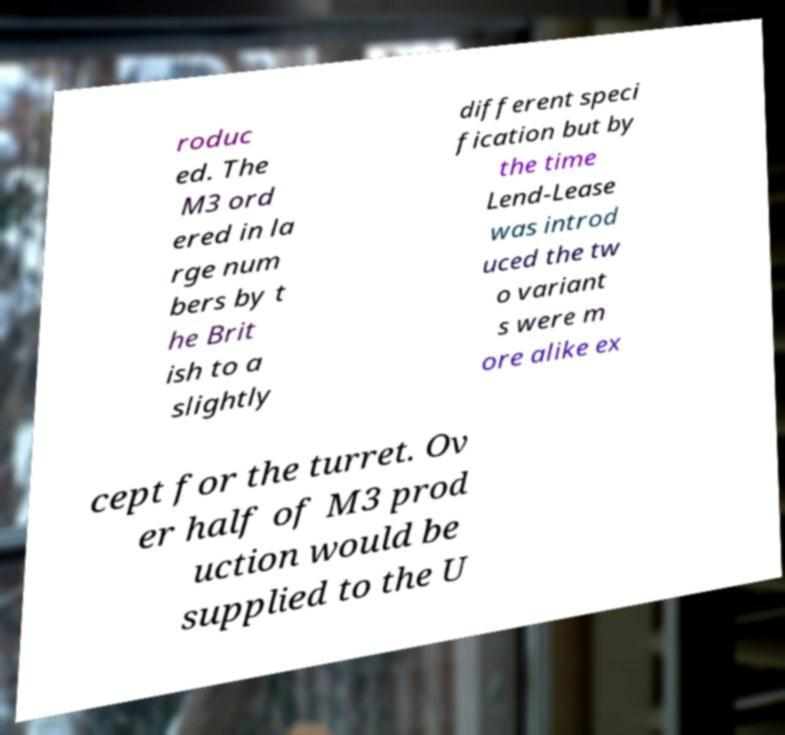Can you read and provide the text displayed in the image?This photo seems to have some interesting text. Can you extract and type it out for me? roduc ed. The M3 ord ered in la rge num bers by t he Brit ish to a slightly different speci fication but by the time Lend-Lease was introd uced the tw o variant s were m ore alike ex cept for the turret. Ov er half of M3 prod uction would be supplied to the U 